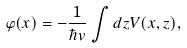Convert formula to latex. <formula><loc_0><loc_0><loc_500><loc_500>\varphi ( x ) = - \frac { 1 } { \hbar { v } } \int d z V ( x , z ) ,</formula> 